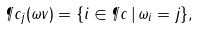<formula> <loc_0><loc_0><loc_500><loc_500>\P c _ { j } ( \omega v ) = \{ i \in \P c \, | \, \omega _ { i } = j \} ,</formula> 